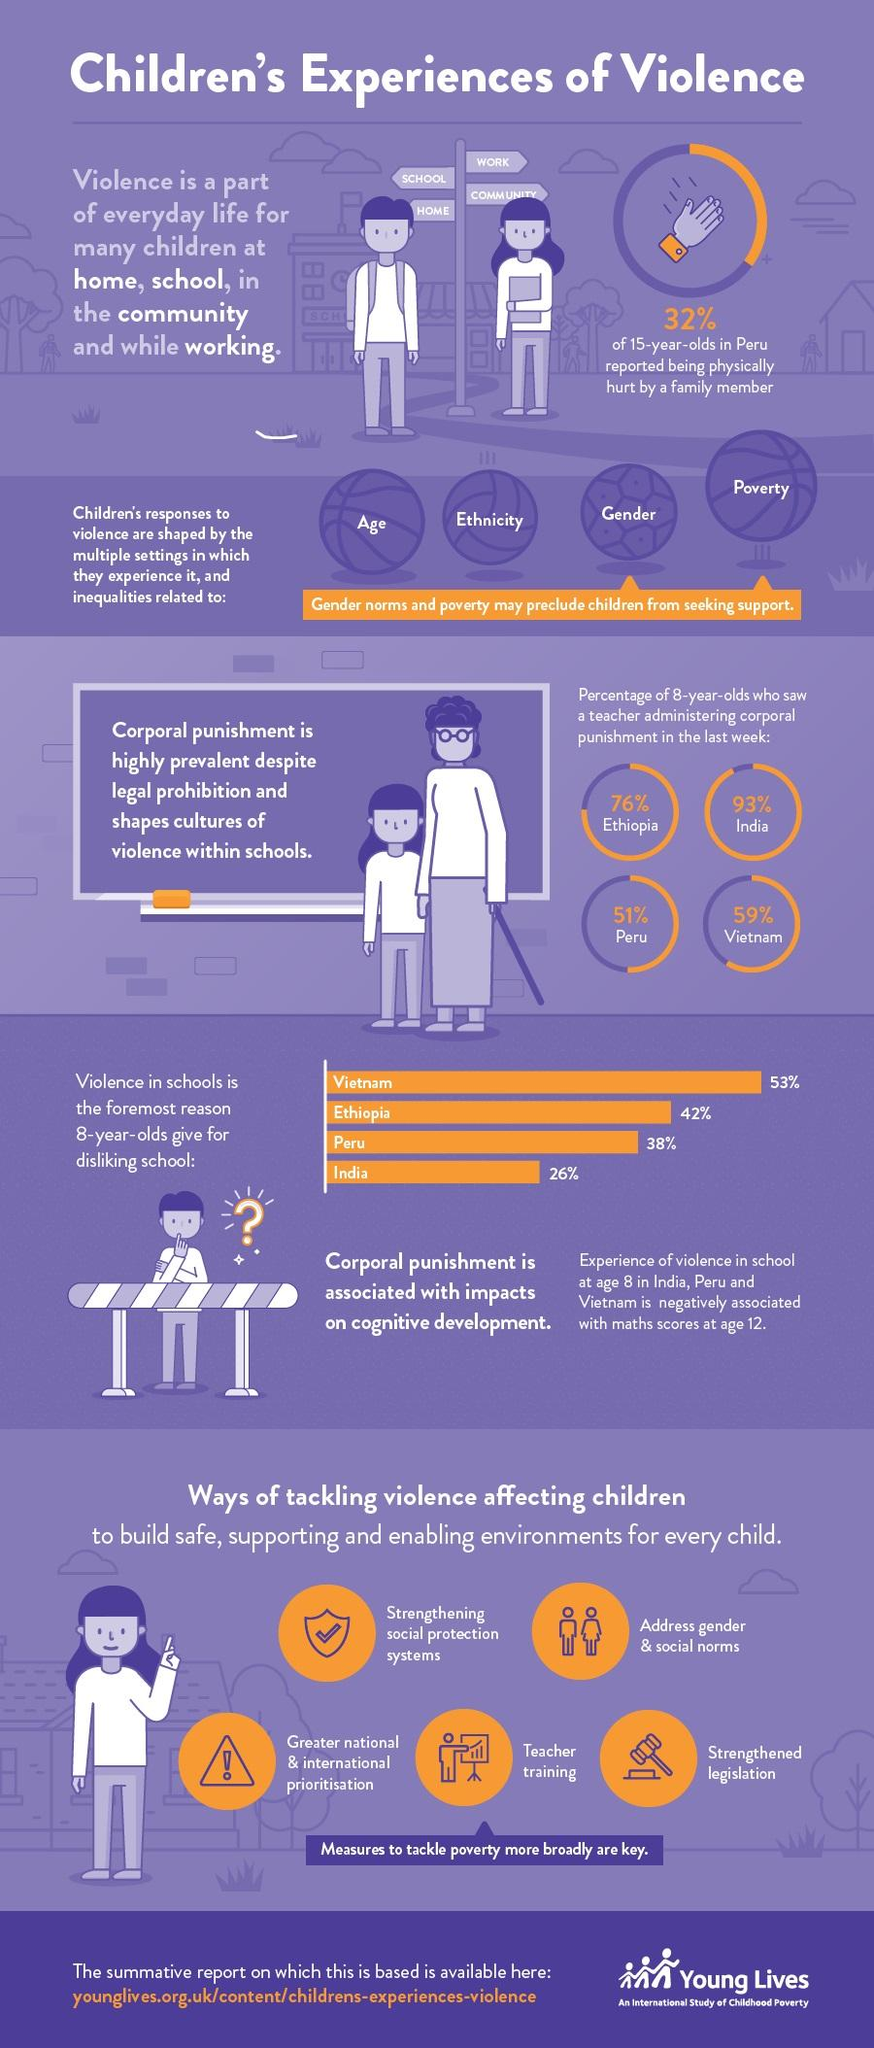Point out several critical features in this image. According to recent data, a staggering 93% of 8-year-olds in India were subjected to corporal punishment by a teacher last week. A recent survey in Vietnam revealed that 59% of 8-year-olds reported witnessing a teacher administering corporal punishment in the past week. According to a report, 68% of 15-year-olds in Peru stated that they had not been physically hurt by a family member. 